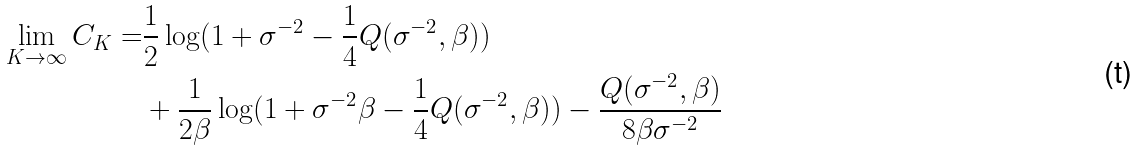<formula> <loc_0><loc_0><loc_500><loc_500>\lim _ { K \to \infty } C _ { K } = & \frac { 1 } { 2 } \log ( 1 + \sigma ^ { - 2 } - \frac { 1 } { 4 } Q ( \sigma ^ { - 2 } , \beta ) ) \\ & + \frac { 1 } { 2 \beta } \log ( 1 + \sigma ^ { - 2 } \beta - \frac { 1 } { 4 } Q ( \sigma ^ { - 2 } , \beta ) ) - \frac { Q ( \sigma ^ { - 2 } , \beta ) } { 8 \beta \sigma ^ { - 2 } }</formula> 